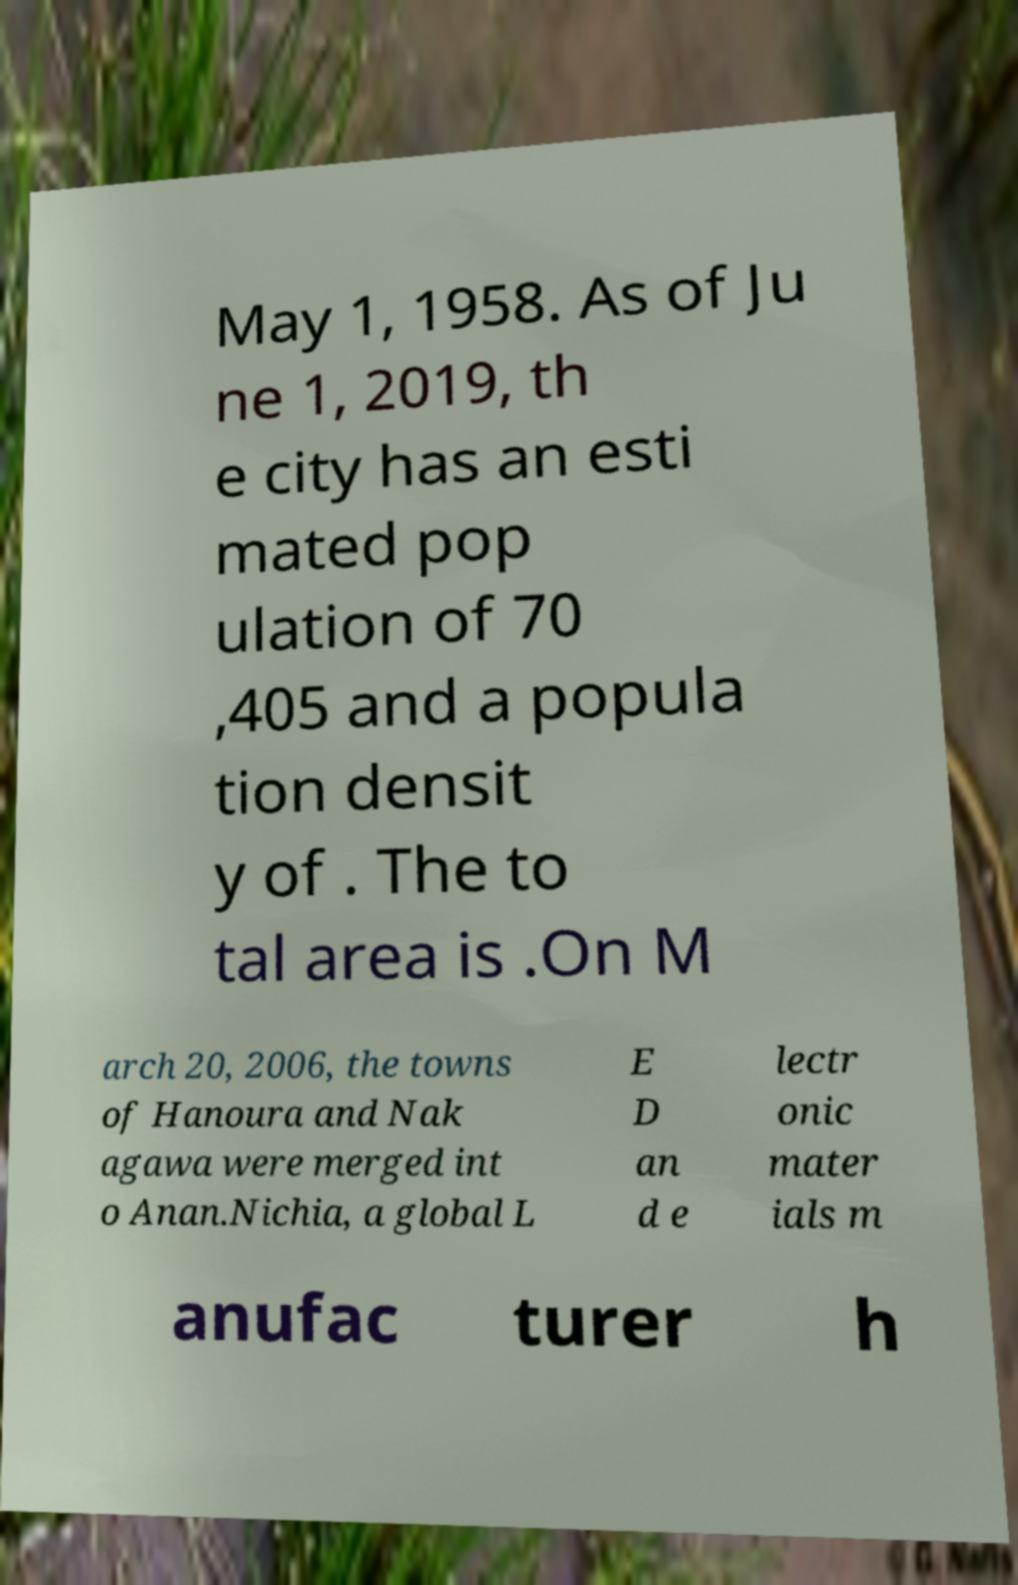Can you read and provide the text displayed in the image?This photo seems to have some interesting text. Can you extract and type it out for me? May 1, 1958. As of Ju ne 1, 2019, th e city has an esti mated pop ulation of 70 ,405 and a popula tion densit y of . The to tal area is .On M arch 20, 2006, the towns of Hanoura and Nak agawa were merged int o Anan.Nichia, a global L E D an d e lectr onic mater ials m anufac turer h 